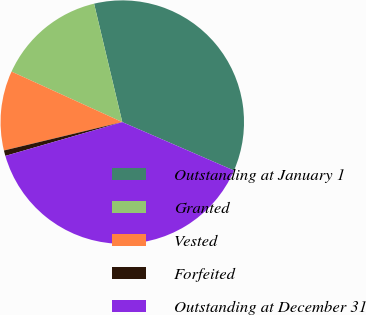<chart> <loc_0><loc_0><loc_500><loc_500><pie_chart><fcel>Outstanding at January 1<fcel>Granted<fcel>Vested<fcel>Forfeited<fcel>Outstanding at December 31<nl><fcel>35.24%<fcel>14.47%<fcel>10.56%<fcel>0.73%<fcel>39.01%<nl></chart> 